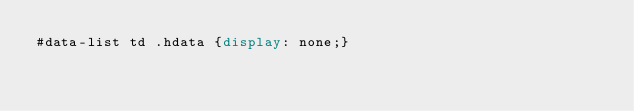<code> <loc_0><loc_0><loc_500><loc_500><_CSS_>#data-list td .hdata {display: none;}
</code> 